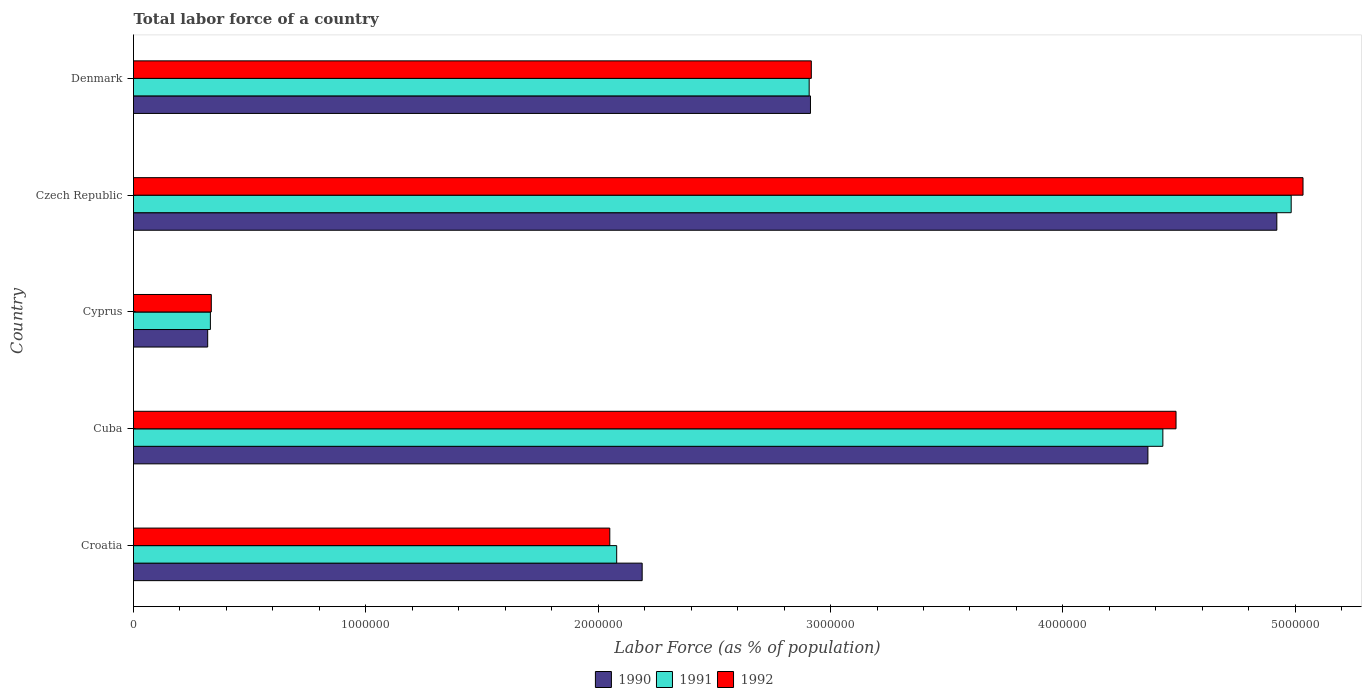How many different coloured bars are there?
Ensure brevity in your answer.  3. How many groups of bars are there?
Keep it short and to the point. 5. Are the number of bars on each tick of the Y-axis equal?
Offer a very short reply. Yes. How many bars are there on the 1st tick from the bottom?
Your answer should be very brief. 3. What is the label of the 5th group of bars from the top?
Offer a terse response. Croatia. What is the percentage of labor force in 1990 in Cuba?
Ensure brevity in your answer.  4.37e+06. Across all countries, what is the maximum percentage of labor force in 1992?
Offer a very short reply. 5.03e+06. Across all countries, what is the minimum percentage of labor force in 1991?
Make the answer very short. 3.31e+05. In which country was the percentage of labor force in 1991 maximum?
Your response must be concise. Czech Republic. In which country was the percentage of labor force in 1990 minimum?
Keep it short and to the point. Cyprus. What is the total percentage of labor force in 1990 in the graph?
Your response must be concise. 1.47e+07. What is the difference between the percentage of labor force in 1992 in Croatia and that in Denmark?
Provide a succinct answer. -8.67e+05. What is the difference between the percentage of labor force in 1992 in Cuba and the percentage of labor force in 1990 in Czech Republic?
Your response must be concise. -4.34e+05. What is the average percentage of labor force in 1990 per country?
Provide a short and direct response. 2.94e+06. What is the difference between the percentage of labor force in 1992 and percentage of labor force in 1990 in Cuba?
Give a very brief answer. 1.21e+05. In how many countries, is the percentage of labor force in 1991 greater than 3200000 %?
Offer a terse response. 2. What is the ratio of the percentage of labor force in 1991 in Croatia to that in Denmark?
Give a very brief answer. 0.72. Is the percentage of labor force in 1991 in Croatia less than that in Cuba?
Provide a succinct answer. Yes. What is the difference between the highest and the second highest percentage of labor force in 1990?
Offer a terse response. 5.55e+05. What is the difference between the highest and the lowest percentage of labor force in 1991?
Offer a very short reply. 4.65e+06. In how many countries, is the percentage of labor force in 1992 greater than the average percentage of labor force in 1992 taken over all countries?
Make the answer very short. 2. What does the 2nd bar from the bottom in Czech Republic represents?
Give a very brief answer. 1991. Are the values on the major ticks of X-axis written in scientific E-notation?
Provide a succinct answer. No. Does the graph contain any zero values?
Your answer should be compact. No. How many legend labels are there?
Provide a succinct answer. 3. What is the title of the graph?
Your answer should be very brief. Total labor force of a country. Does "1986" appear as one of the legend labels in the graph?
Ensure brevity in your answer.  No. What is the label or title of the X-axis?
Your answer should be compact. Labor Force (as % of population). What is the Labor Force (as % of population) of 1990 in Croatia?
Your answer should be compact. 2.19e+06. What is the Labor Force (as % of population) in 1991 in Croatia?
Your answer should be very brief. 2.08e+06. What is the Labor Force (as % of population) of 1992 in Croatia?
Provide a short and direct response. 2.05e+06. What is the Labor Force (as % of population) of 1990 in Cuba?
Offer a terse response. 4.37e+06. What is the Labor Force (as % of population) of 1991 in Cuba?
Keep it short and to the point. 4.43e+06. What is the Labor Force (as % of population) in 1992 in Cuba?
Ensure brevity in your answer.  4.49e+06. What is the Labor Force (as % of population) in 1990 in Cyprus?
Keep it short and to the point. 3.19e+05. What is the Labor Force (as % of population) in 1991 in Cyprus?
Your answer should be compact. 3.31e+05. What is the Labor Force (as % of population) of 1992 in Cyprus?
Provide a succinct answer. 3.35e+05. What is the Labor Force (as % of population) in 1990 in Czech Republic?
Ensure brevity in your answer.  4.92e+06. What is the Labor Force (as % of population) of 1991 in Czech Republic?
Offer a very short reply. 4.98e+06. What is the Labor Force (as % of population) in 1992 in Czech Republic?
Provide a succinct answer. 5.03e+06. What is the Labor Force (as % of population) of 1990 in Denmark?
Your response must be concise. 2.91e+06. What is the Labor Force (as % of population) of 1991 in Denmark?
Your response must be concise. 2.91e+06. What is the Labor Force (as % of population) in 1992 in Denmark?
Offer a very short reply. 2.92e+06. Across all countries, what is the maximum Labor Force (as % of population) in 1990?
Offer a very short reply. 4.92e+06. Across all countries, what is the maximum Labor Force (as % of population) of 1991?
Your response must be concise. 4.98e+06. Across all countries, what is the maximum Labor Force (as % of population) of 1992?
Your answer should be very brief. 5.03e+06. Across all countries, what is the minimum Labor Force (as % of population) of 1990?
Your answer should be very brief. 3.19e+05. Across all countries, what is the minimum Labor Force (as % of population) of 1991?
Your answer should be compact. 3.31e+05. Across all countries, what is the minimum Labor Force (as % of population) in 1992?
Your answer should be compact. 3.35e+05. What is the total Labor Force (as % of population) in 1990 in the graph?
Provide a short and direct response. 1.47e+07. What is the total Labor Force (as % of population) in 1991 in the graph?
Offer a terse response. 1.47e+07. What is the total Labor Force (as % of population) in 1992 in the graph?
Keep it short and to the point. 1.48e+07. What is the difference between the Labor Force (as % of population) of 1990 in Croatia and that in Cuba?
Provide a short and direct response. -2.18e+06. What is the difference between the Labor Force (as % of population) in 1991 in Croatia and that in Cuba?
Provide a succinct answer. -2.35e+06. What is the difference between the Labor Force (as % of population) of 1992 in Croatia and that in Cuba?
Ensure brevity in your answer.  -2.44e+06. What is the difference between the Labor Force (as % of population) of 1990 in Croatia and that in Cyprus?
Your answer should be very brief. 1.87e+06. What is the difference between the Labor Force (as % of population) of 1991 in Croatia and that in Cyprus?
Your response must be concise. 1.75e+06. What is the difference between the Labor Force (as % of population) of 1992 in Croatia and that in Cyprus?
Provide a succinct answer. 1.72e+06. What is the difference between the Labor Force (as % of population) in 1990 in Croatia and that in Czech Republic?
Your response must be concise. -2.73e+06. What is the difference between the Labor Force (as % of population) in 1991 in Croatia and that in Czech Republic?
Give a very brief answer. -2.90e+06. What is the difference between the Labor Force (as % of population) in 1992 in Croatia and that in Czech Republic?
Offer a terse response. -2.98e+06. What is the difference between the Labor Force (as % of population) of 1990 in Croatia and that in Denmark?
Keep it short and to the point. -7.24e+05. What is the difference between the Labor Force (as % of population) in 1991 in Croatia and that in Denmark?
Provide a succinct answer. -8.28e+05. What is the difference between the Labor Force (as % of population) in 1992 in Croatia and that in Denmark?
Make the answer very short. -8.67e+05. What is the difference between the Labor Force (as % of population) of 1990 in Cuba and that in Cyprus?
Provide a succinct answer. 4.05e+06. What is the difference between the Labor Force (as % of population) in 1991 in Cuba and that in Cyprus?
Your response must be concise. 4.10e+06. What is the difference between the Labor Force (as % of population) of 1992 in Cuba and that in Cyprus?
Ensure brevity in your answer.  4.15e+06. What is the difference between the Labor Force (as % of population) of 1990 in Cuba and that in Czech Republic?
Your answer should be very brief. -5.55e+05. What is the difference between the Labor Force (as % of population) in 1991 in Cuba and that in Czech Republic?
Give a very brief answer. -5.52e+05. What is the difference between the Labor Force (as % of population) in 1992 in Cuba and that in Czech Republic?
Your answer should be very brief. -5.47e+05. What is the difference between the Labor Force (as % of population) in 1990 in Cuba and that in Denmark?
Provide a succinct answer. 1.45e+06. What is the difference between the Labor Force (as % of population) of 1991 in Cuba and that in Denmark?
Keep it short and to the point. 1.52e+06. What is the difference between the Labor Force (as % of population) in 1992 in Cuba and that in Denmark?
Provide a succinct answer. 1.57e+06. What is the difference between the Labor Force (as % of population) of 1990 in Cyprus and that in Czech Republic?
Provide a short and direct response. -4.60e+06. What is the difference between the Labor Force (as % of population) of 1991 in Cyprus and that in Czech Republic?
Give a very brief answer. -4.65e+06. What is the difference between the Labor Force (as % of population) in 1992 in Cyprus and that in Czech Republic?
Offer a terse response. -4.70e+06. What is the difference between the Labor Force (as % of population) in 1990 in Cyprus and that in Denmark?
Ensure brevity in your answer.  -2.59e+06. What is the difference between the Labor Force (as % of population) in 1991 in Cyprus and that in Denmark?
Give a very brief answer. -2.58e+06. What is the difference between the Labor Force (as % of population) in 1992 in Cyprus and that in Denmark?
Provide a succinct answer. -2.58e+06. What is the difference between the Labor Force (as % of population) in 1990 in Czech Republic and that in Denmark?
Provide a short and direct response. 2.01e+06. What is the difference between the Labor Force (as % of population) in 1991 in Czech Republic and that in Denmark?
Provide a succinct answer. 2.07e+06. What is the difference between the Labor Force (as % of population) in 1992 in Czech Republic and that in Denmark?
Your answer should be compact. 2.12e+06. What is the difference between the Labor Force (as % of population) in 1990 in Croatia and the Labor Force (as % of population) in 1991 in Cuba?
Your response must be concise. -2.24e+06. What is the difference between the Labor Force (as % of population) of 1990 in Croatia and the Labor Force (as % of population) of 1992 in Cuba?
Your answer should be very brief. -2.30e+06. What is the difference between the Labor Force (as % of population) of 1991 in Croatia and the Labor Force (as % of population) of 1992 in Cuba?
Ensure brevity in your answer.  -2.41e+06. What is the difference between the Labor Force (as % of population) in 1990 in Croatia and the Labor Force (as % of population) in 1991 in Cyprus?
Your answer should be very brief. 1.86e+06. What is the difference between the Labor Force (as % of population) in 1990 in Croatia and the Labor Force (as % of population) in 1992 in Cyprus?
Your answer should be compact. 1.85e+06. What is the difference between the Labor Force (as % of population) in 1991 in Croatia and the Labor Force (as % of population) in 1992 in Cyprus?
Give a very brief answer. 1.74e+06. What is the difference between the Labor Force (as % of population) of 1990 in Croatia and the Labor Force (as % of population) of 1991 in Czech Republic?
Keep it short and to the point. -2.79e+06. What is the difference between the Labor Force (as % of population) of 1990 in Croatia and the Labor Force (as % of population) of 1992 in Czech Republic?
Ensure brevity in your answer.  -2.84e+06. What is the difference between the Labor Force (as % of population) of 1991 in Croatia and the Labor Force (as % of population) of 1992 in Czech Republic?
Offer a very short reply. -2.95e+06. What is the difference between the Labor Force (as % of population) in 1990 in Croatia and the Labor Force (as % of population) in 1991 in Denmark?
Your answer should be compact. -7.19e+05. What is the difference between the Labor Force (as % of population) of 1990 in Croatia and the Labor Force (as % of population) of 1992 in Denmark?
Ensure brevity in your answer.  -7.28e+05. What is the difference between the Labor Force (as % of population) of 1991 in Croatia and the Labor Force (as % of population) of 1992 in Denmark?
Offer a terse response. -8.38e+05. What is the difference between the Labor Force (as % of population) of 1990 in Cuba and the Labor Force (as % of population) of 1991 in Cyprus?
Make the answer very short. 4.04e+06. What is the difference between the Labor Force (as % of population) in 1990 in Cuba and the Labor Force (as % of population) in 1992 in Cyprus?
Make the answer very short. 4.03e+06. What is the difference between the Labor Force (as % of population) in 1991 in Cuba and the Labor Force (as % of population) in 1992 in Cyprus?
Give a very brief answer. 4.10e+06. What is the difference between the Labor Force (as % of population) of 1990 in Cuba and the Labor Force (as % of population) of 1991 in Czech Republic?
Provide a short and direct response. -6.17e+05. What is the difference between the Labor Force (as % of population) of 1990 in Cuba and the Labor Force (as % of population) of 1992 in Czech Republic?
Provide a succinct answer. -6.68e+05. What is the difference between the Labor Force (as % of population) of 1991 in Cuba and the Labor Force (as % of population) of 1992 in Czech Republic?
Offer a terse response. -6.03e+05. What is the difference between the Labor Force (as % of population) of 1990 in Cuba and the Labor Force (as % of population) of 1991 in Denmark?
Offer a very short reply. 1.46e+06. What is the difference between the Labor Force (as % of population) of 1990 in Cuba and the Labor Force (as % of population) of 1992 in Denmark?
Make the answer very short. 1.45e+06. What is the difference between the Labor Force (as % of population) of 1991 in Cuba and the Labor Force (as % of population) of 1992 in Denmark?
Provide a succinct answer. 1.51e+06. What is the difference between the Labor Force (as % of population) in 1990 in Cyprus and the Labor Force (as % of population) in 1991 in Czech Republic?
Provide a succinct answer. -4.66e+06. What is the difference between the Labor Force (as % of population) of 1990 in Cyprus and the Labor Force (as % of population) of 1992 in Czech Republic?
Your response must be concise. -4.71e+06. What is the difference between the Labor Force (as % of population) of 1991 in Cyprus and the Labor Force (as % of population) of 1992 in Czech Republic?
Provide a short and direct response. -4.70e+06. What is the difference between the Labor Force (as % of population) in 1990 in Cyprus and the Labor Force (as % of population) in 1991 in Denmark?
Make the answer very short. -2.59e+06. What is the difference between the Labor Force (as % of population) of 1990 in Cyprus and the Labor Force (as % of population) of 1992 in Denmark?
Offer a terse response. -2.60e+06. What is the difference between the Labor Force (as % of population) of 1991 in Cyprus and the Labor Force (as % of population) of 1992 in Denmark?
Offer a very short reply. -2.59e+06. What is the difference between the Labor Force (as % of population) in 1990 in Czech Republic and the Labor Force (as % of population) in 1991 in Denmark?
Offer a terse response. 2.01e+06. What is the difference between the Labor Force (as % of population) in 1990 in Czech Republic and the Labor Force (as % of population) in 1992 in Denmark?
Keep it short and to the point. 2.00e+06. What is the difference between the Labor Force (as % of population) in 1991 in Czech Republic and the Labor Force (as % of population) in 1992 in Denmark?
Your answer should be compact. 2.07e+06. What is the average Labor Force (as % of population) of 1990 per country?
Your answer should be compact. 2.94e+06. What is the average Labor Force (as % of population) of 1991 per country?
Make the answer very short. 2.95e+06. What is the average Labor Force (as % of population) of 1992 per country?
Your response must be concise. 2.96e+06. What is the difference between the Labor Force (as % of population) of 1990 and Labor Force (as % of population) of 1991 in Croatia?
Offer a very short reply. 1.10e+05. What is the difference between the Labor Force (as % of population) of 1990 and Labor Force (as % of population) of 1992 in Croatia?
Offer a very short reply. 1.39e+05. What is the difference between the Labor Force (as % of population) in 1991 and Labor Force (as % of population) in 1992 in Croatia?
Make the answer very short. 2.97e+04. What is the difference between the Labor Force (as % of population) in 1990 and Labor Force (as % of population) in 1991 in Cuba?
Provide a succinct answer. -6.43e+04. What is the difference between the Labor Force (as % of population) of 1990 and Labor Force (as % of population) of 1992 in Cuba?
Provide a succinct answer. -1.21e+05. What is the difference between the Labor Force (as % of population) of 1991 and Labor Force (as % of population) of 1992 in Cuba?
Your answer should be very brief. -5.67e+04. What is the difference between the Labor Force (as % of population) in 1990 and Labor Force (as % of population) in 1991 in Cyprus?
Your answer should be compact. -1.16e+04. What is the difference between the Labor Force (as % of population) in 1990 and Labor Force (as % of population) in 1992 in Cyprus?
Ensure brevity in your answer.  -1.55e+04. What is the difference between the Labor Force (as % of population) in 1991 and Labor Force (as % of population) in 1992 in Cyprus?
Give a very brief answer. -3948. What is the difference between the Labor Force (as % of population) of 1990 and Labor Force (as % of population) of 1991 in Czech Republic?
Your response must be concise. -6.18e+04. What is the difference between the Labor Force (as % of population) in 1990 and Labor Force (as % of population) in 1992 in Czech Republic?
Your answer should be very brief. -1.13e+05. What is the difference between the Labor Force (as % of population) of 1991 and Labor Force (as % of population) of 1992 in Czech Republic?
Ensure brevity in your answer.  -5.09e+04. What is the difference between the Labor Force (as % of population) of 1990 and Labor Force (as % of population) of 1991 in Denmark?
Offer a terse response. 5525. What is the difference between the Labor Force (as % of population) in 1990 and Labor Force (as % of population) in 1992 in Denmark?
Your answer should be compact. -3632. What is the difference between the Labor Force (as % of population) in 1991 and Labor Force (as % of population) in 1992 in Denmark?
Ensure brevity in your answer.  -9157. What is the ratio of the Labor Force (as % of population) in 1990 in Croatia to that in Cuba?
Provide a succinct answer. 0.5. What is the ratio of the Labor Force (as % of population) in 1991 in Croatia to that in Cuba?
Your answer should be very brief. 0.47. What is the ratio of the Labor Force (as % of population) in 1992 in Croatia to that in Cuba?
Provide a succinct answer. 0.46. What is the ratio of the Labor Force (as % of population) of 1990 in Croatia to that in Cyprus?
Provide a short and direct response. 6.86. What is the ratio of the Labor Force (as % of population) in 1991 in Croatia to that in Cyprus?
Offer a terse response. 6.29. What is the ratio of the Labor Force (as % of population) of 1992 in Croatia to that in Cyprus?
Make the answer very short. 6.12. What is the ratio of the Labor Force (as % of population) in 1990 in Croatia to that in Czech Republic?
Your answer should be compact. 0.44. What is the ratio of the Labor Force (as % of population) in 1991 in Croatia to that in Czech Republic?
Your response must be concise. 0.42. What is the ratio of the Labor Force (as % of population) of 1992 in Croatia to that in Czech Republic?
Give a very brief answer. 0.41. What is the ratio of the Labor Force (as % of population) in 1990 in Croatia to that in Denmark?
Provide a succinct answer. 0.75. What is the ratio of the Labor Force (as % of population) in 1991 in Croatia to that in Denmark?
Offer a terse response. 0.72. What is the ratio of the Labor Force (as % of population) of 1992 in Croatia to that in Denmark?
Your response must be concise. 0.7. What is the ratio of the Labor Force (as % of population) in 1990 in Cuba to that in Cyprus?
Make the answer very short. 13.67. What is the ratio of the Labor Force (as % of population) in 1991 in Cuba to that in Cyprus?
Your response must be concise. 13.39. What is the ratio of the Labor Force (as % of population) of 1992 in Cuba to that in Cyprus?
Provide a succinct answer. 13.4. What is the ratio of the Labor Force (as % of population) in 1990 in Cuba to that in Czech Republic?
Make the answer very short. 0.89. What is the ratio of the Labor Force (as % of population) of 1991 in Cuba to that in Czech Republic?
Offer a very short reply. 0.89. What is the ratio of the Labor Force (as % of population) of 1992 in Cuba to that in Czech Republic?
Your answer should be very brief. 0.89. What is the ratio of the Labor Force (as % of population) of 1990 in Cuba to that in Denmark?
Offer a very short reply. 1.5. What is the ratio of the Labor Force (as % of population) of 1991 in Cuba to that in Denmark?
Your answer should be compact. 1.52. What is the ratio of the Labor Force (as % of population) in 1992 in Cuba to that in Denmark?
Your response must be concise. 1.54. What is the ratio of the Labor Force (as % of population) of 1990 in Cyprus to that in Czech Republic?
Ensure brevity in your answer.  0.06. What is the ratio of the Labor Force (as % of population) of 1991 in Cyprus to that in Czech Republic?
Offer a terse response. 0.07. What is the ratio of the Labor Force (as % of population) in 1992 in Cyprus to that in Czech Republic?
Make the answer very short. 0.07. What is the ratio of the Labor Force (as % of population) in 1990 in Cyprus to that in Denmark?
Provide a short and direct response. 0.11. What is the ratio of the Labor Force (as % of population) of 1991 in Cyprus to that in Denmark?
Ensure brevity in your answer.  0.11. What is the ratio of the Labor Force (as % of population) in 1992 in Cyprus to that in Denmark?
Ensure brevity in your answer.  0.11. What is the ratio of the Labor Force (as % of population) in 1990 in Czech Republic to that in Denmark?
Your response must be concise. 1.69. What is the ratio of the Labor Force (as % of population) of 1991 in Czech Republic to that in Denmark?
Provide a succinct answer. 1.71. What is the ratio of the Labor Force (as % of population) in 1992 in Czech Republic to that in Denmark?
Keep it short and to the point. 1.73. What is the difference between the highest and the second highest Labor Force (as % of population) in 1990?
Provide a short and direct response. 5.55e+05. What is the difference between the highest and the second highest Labor Force (as % of population) in 1991?
Provide a succinct answer. 5.52e+05. What is the difference between the highest and the second highest Labor Force (as % of population) in 1992?
Keep it short and to the point. 5.47e+05. What is the difference between the highest and the lowest Labor Force (as % of population) of 1990?
Your answer should be very brief. 4.60e+06. What is the difference between the highest and the lowest Labor Force (as % of population) of 1991?
Give a very brief answer. 4.65e+06. What is the difference between the highest and the lowest Labor Force (as % of population) in 1992?
Your response must be concise. 4.70e+06. 